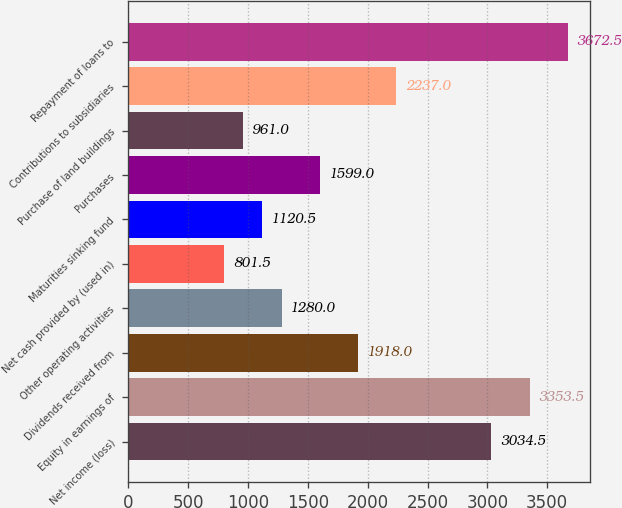<chart> <loc_0><loc_0><loc_500><loc_500><bar_chart><fcel>Net income (loss)<fcel>Equity in earnings of<fcel>Dividends received from<fcel>Other operating activities<fcel>Net cash provided by (used in)<fcel>Maturities sinking fund<fcel>Purchases<fcel>Purchase of land buildings<fcel>Contributions to subsidiaries<fcel>Repayment of loans to<nl><fcel>3034.5<fcel>3353.5<fcel>1918<fcel>1280<fcel>801.5<fcel>1120.5<fcel>1599<fcel>961<fcel>2237<fcel>3672.5<nl></chart> 